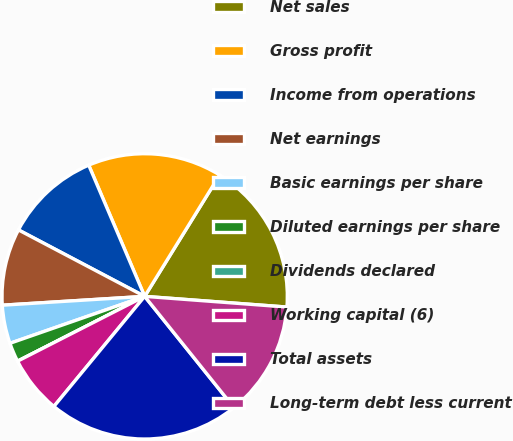Convert chart. <chart><loc_0><loc_0><loc_500><loc_500><pie_chart><fcel>Net sales<fcel>Gross profit<fcel>Income from operations<fcel>Net earnings<fcel>Basic earnings per share<fcel>Diluted earnings per share<fcel>Dividends declared<fcel>Working capital (6)<fcel>Total assets<fcel>Long-term debt less current<nl><fcel>17.39%<fcel>15.22%<fcel>10.87%<fcel>8.7%<fcel>4.35%<fcel>2.17%<fcel>0.0%<fcel>6.52%<fcel>21.74%<fcel>13.04%<nl></chart> 